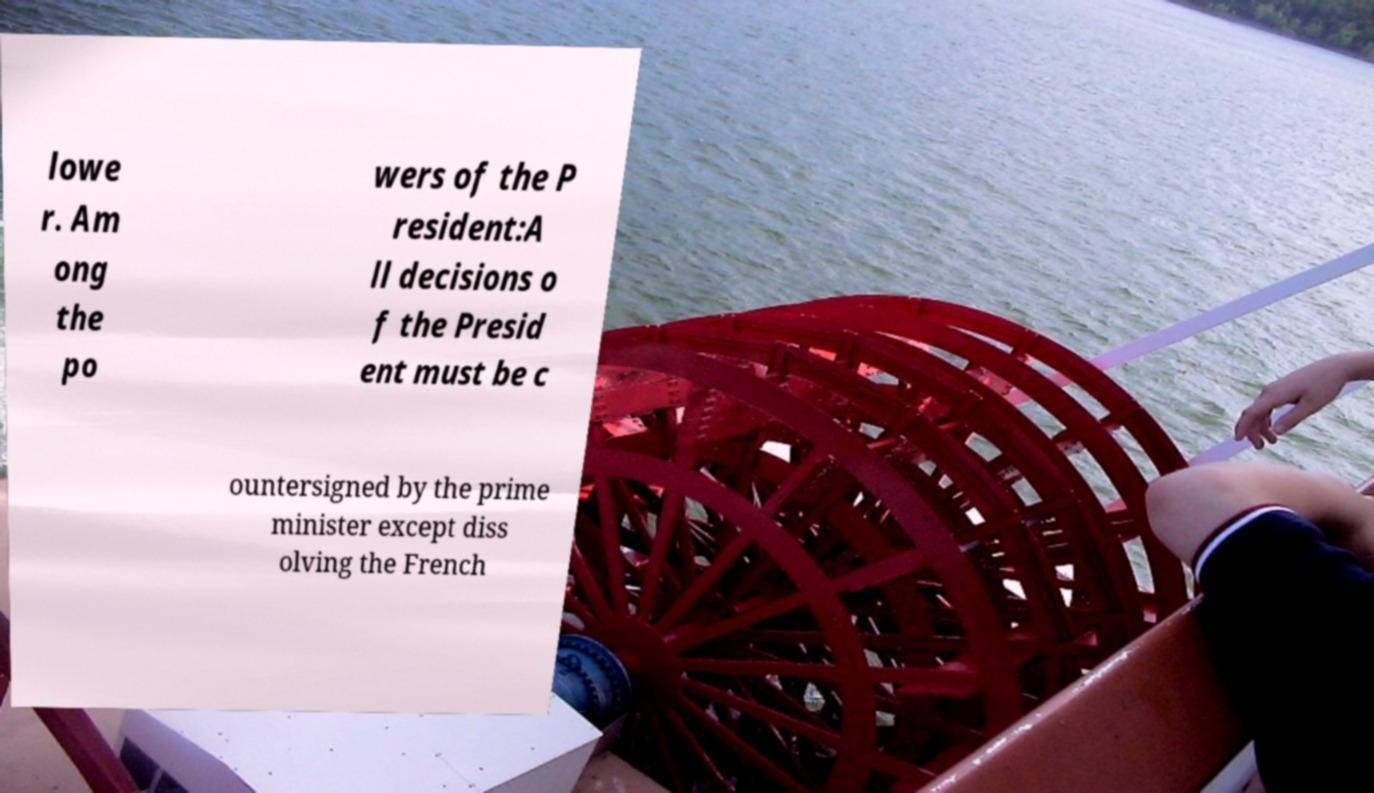Please read and relay the text visible in this image. What does it say? lowe r. Am ong the po wers of the P resident:A ll decisions o f the Presid ent must be c ountersigned by the prime minister except diss olving the French 